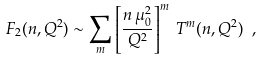<formula> <loc_0><loc_0><loc_500><loc_500>F _ { 2 } ( n , Q ^ { 2 } ) \sim \sum _ { m } \left [ \frac { n \, \mu _ { 0 } ^ { 2 } } { Q ^ { 2 } } \right ] ^ { m } \, T ^ { m } ( n , Q ^ { 2 } ) \ ,</formula> 